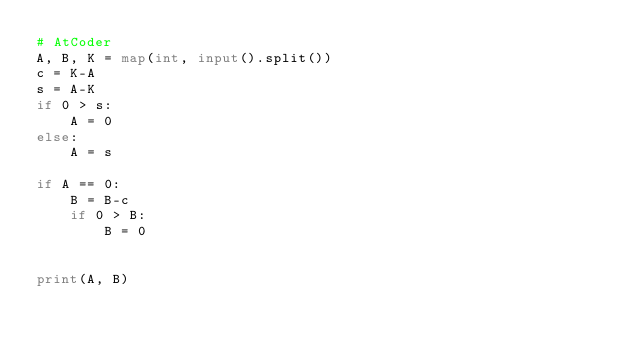<code> <loc_0><loc_0><loc_500><loc_500><_Python_># AtCoder
A, B, K = map(int, input().split())
c = K-A
s = A-K
if 0 > s:
    A = 0
else:
    A = s

if A == 0:
    B = B-c
    if 0 > B:
        B = 0


print(A, B)
</code> 